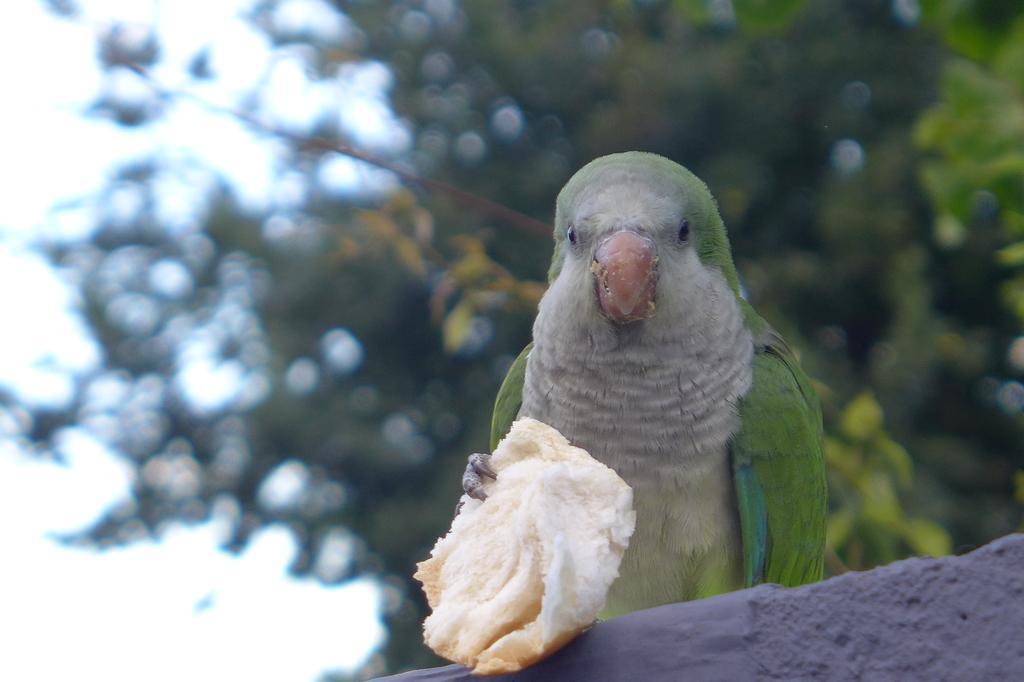Describe this image in one or two sentences. In the picture I can see a parrot is holding some food item. In the background I can see trees. The background of the image is blurred. 